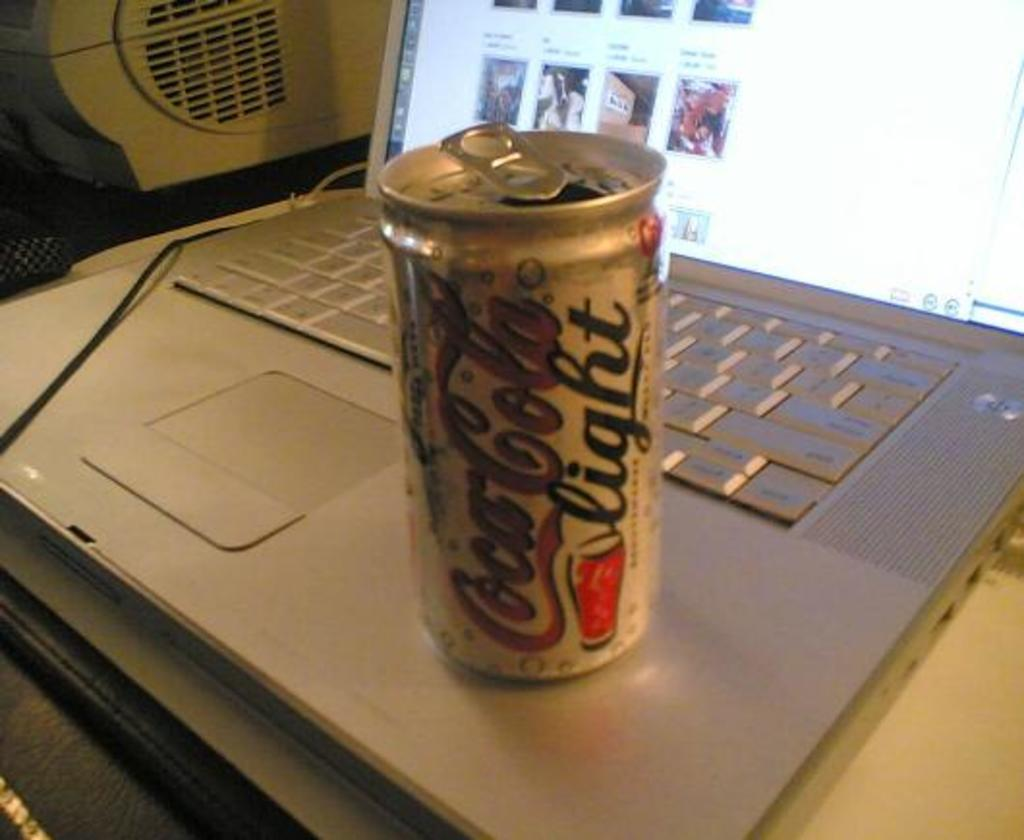<image>
Create a compact narrative representing the image presented. a coca cola can that is on a laptop 